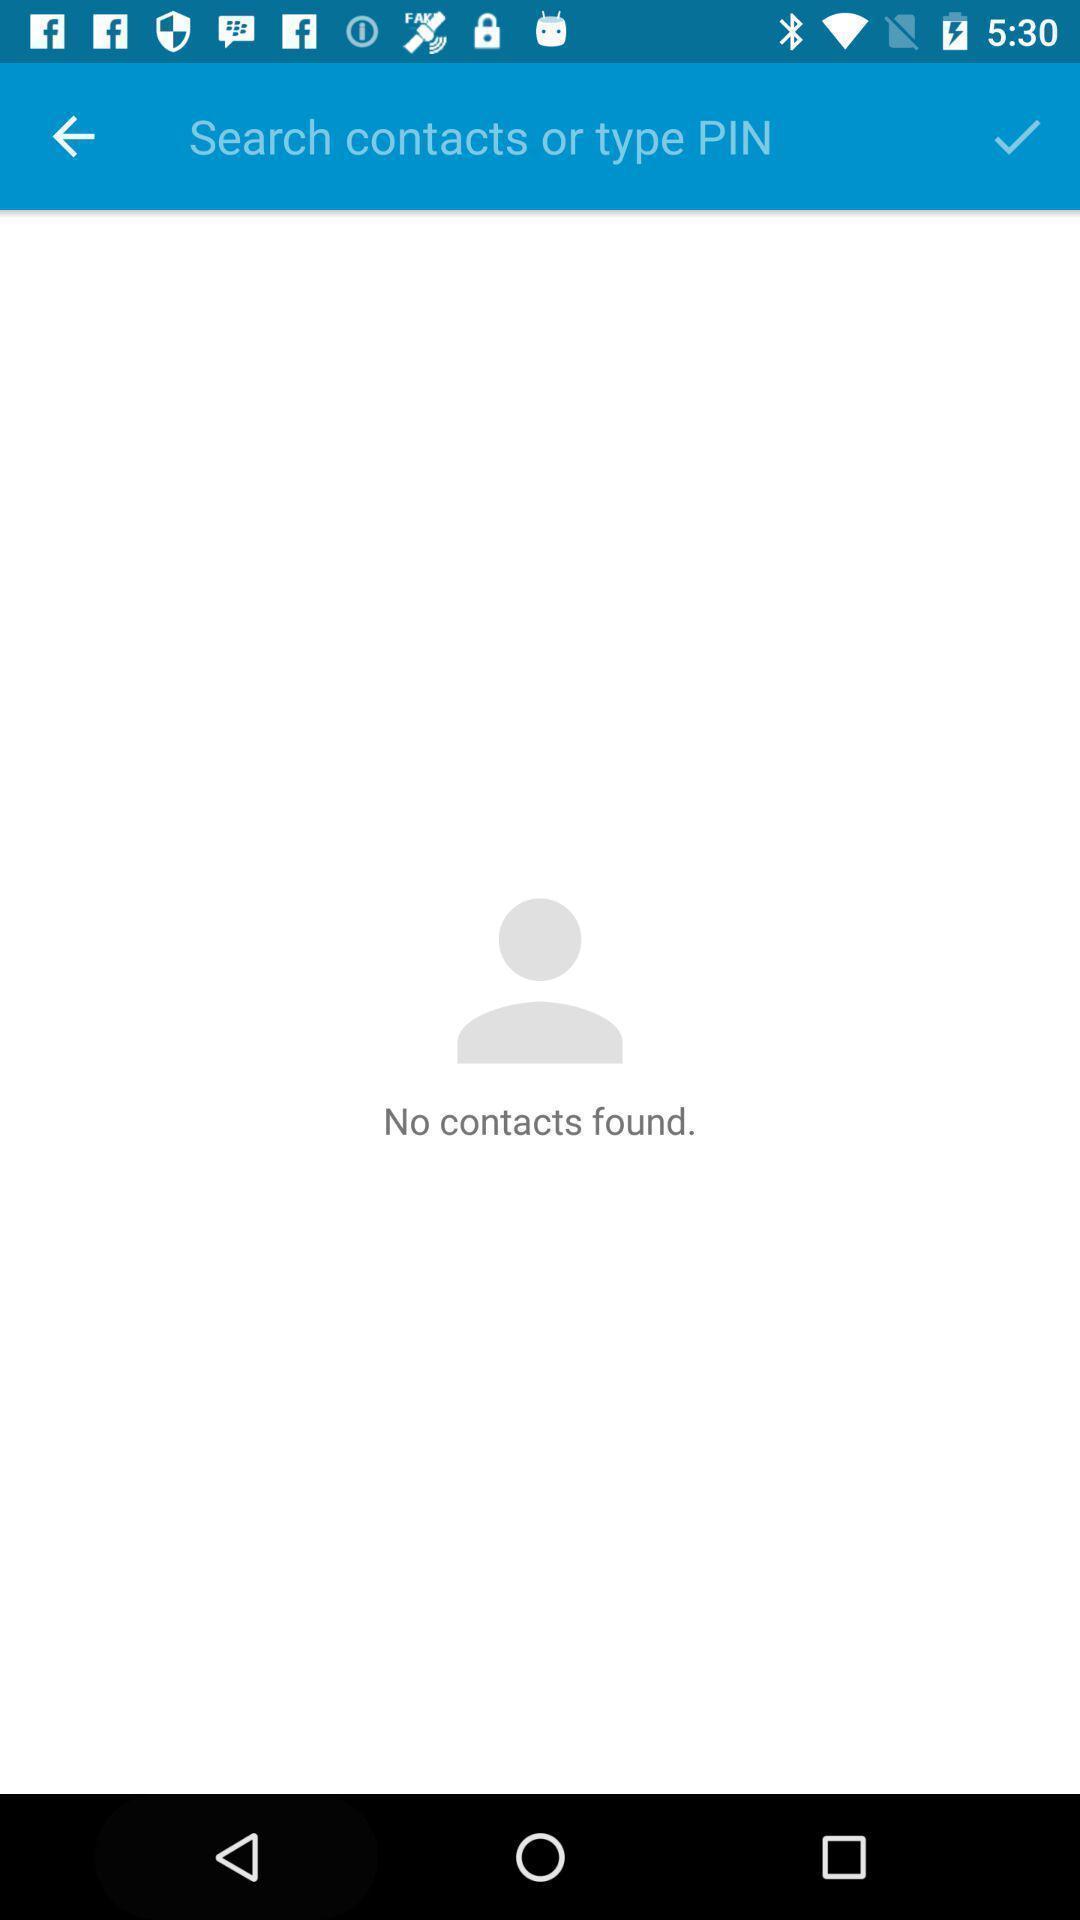Describe the visual elements of this screenshot. Search page shows to find the contacts. 